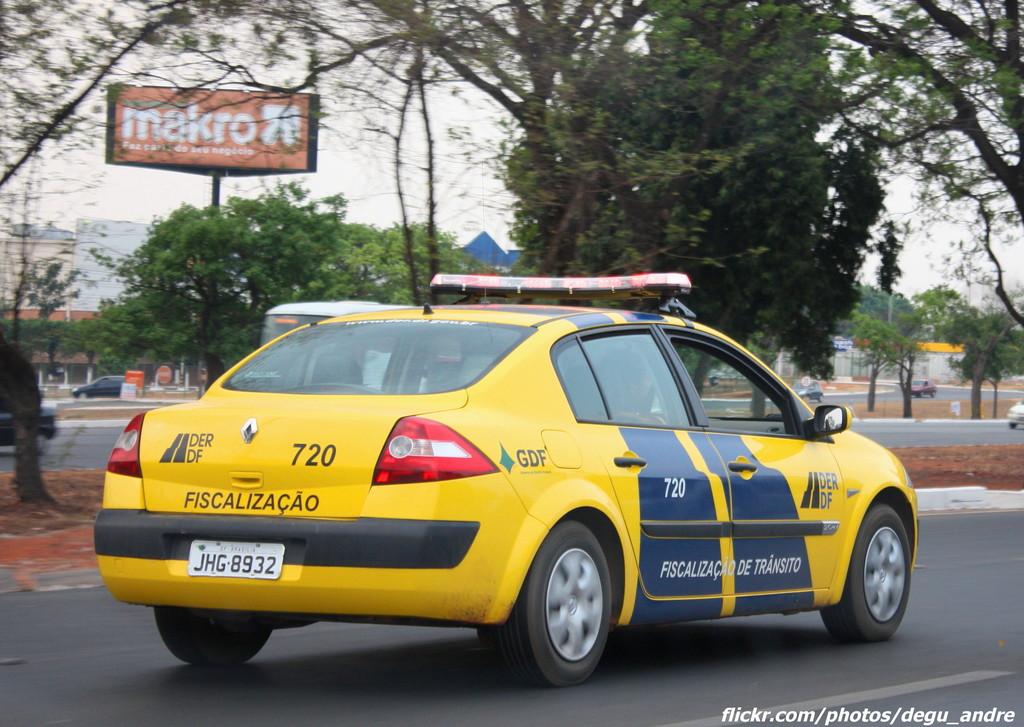What is the police number?
Your answer should be very brief. 720. 